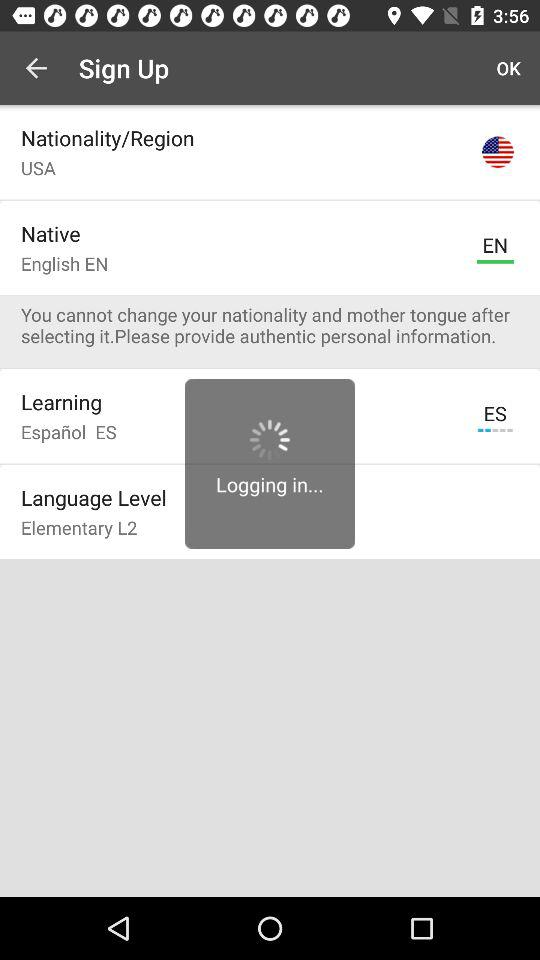Which option is selected?
When the provided information is insufficient, respond with <no answer>. <no answer> 